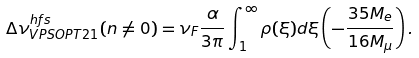Convert formula to latex. <formula><loc_0><loc_0><loc_500><loc_500>\Delta \nu ^ { h f s } _ { V P S O P T 2 1 } ( n \not = 0 ) = \nu _ { F } \frac { \alpha } { 3 \pi } \int _ { 1 } ^ { \infty } \rho ( \xi ) d \xi \left ( - \frac { 3 5 M _ { e } } { 1 6 M _ { \mu } } \right ) .</formula> 